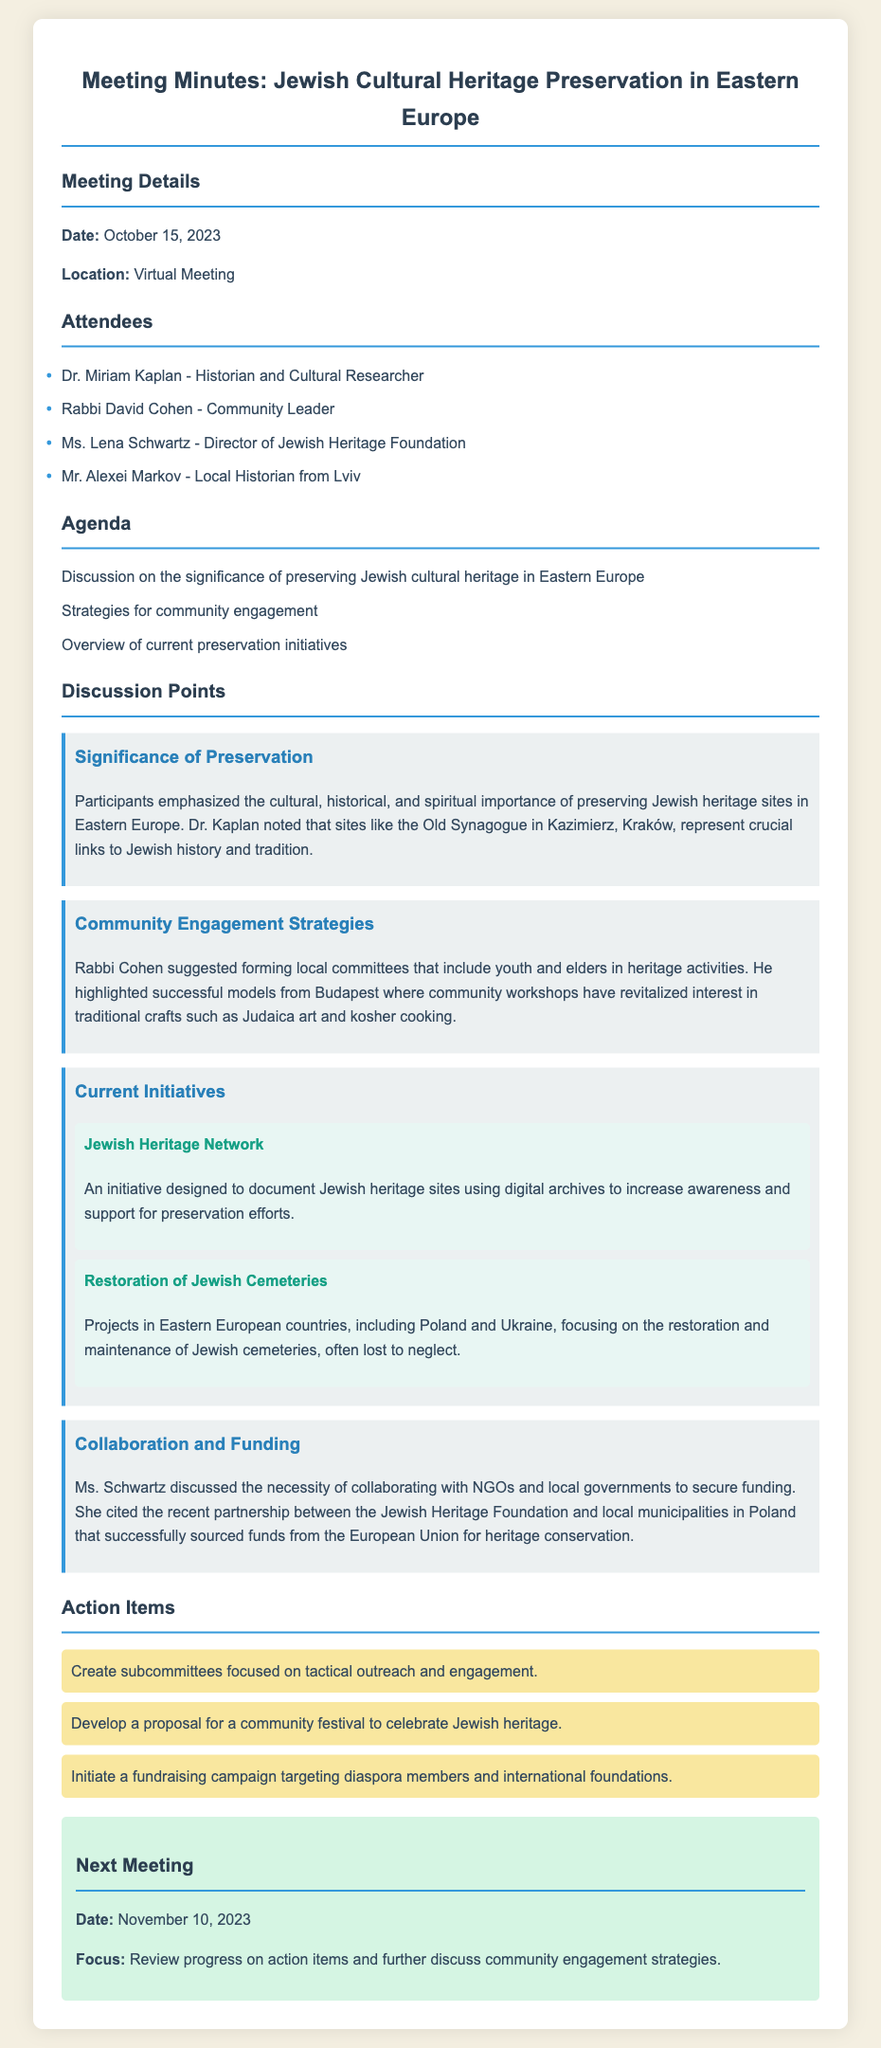What is the date of the meeting? The date of the meeting is mentioned in the meeting details section of the document.
Answer: October 15, 2023 Who is the director of the Jewish Heritage Foundation? The document lists attendees, including the director of a specific foundation, which is relevant to the discussion.
Answer: Ms. Lena Schwartz What initiative focuses on documenting Jewish heritage sites? The document outlines current initiatives and provides names and descriptions of these initiatives.
Answer: Jewish Heritage Network How are community workshops impacting traditional crafts in Budapest? The document highlights the effects of community workshops as discussed by Rabbi Cohen, indicating their success in revitalization.
Answer: Revitalized interest What is one of the action items from the meeting? The action items section lists specific activities that were agreed upon during the discussion.
Answer: Create subcommittees focused on tactical outreach and engagement What is the main focus of the next meeting? The next meeting section specifies the focus of the upcoming gathering, which relates to the continuation of discussion from this meeting.
Answer: Review progress on action items and further discuss community engagement strategies 